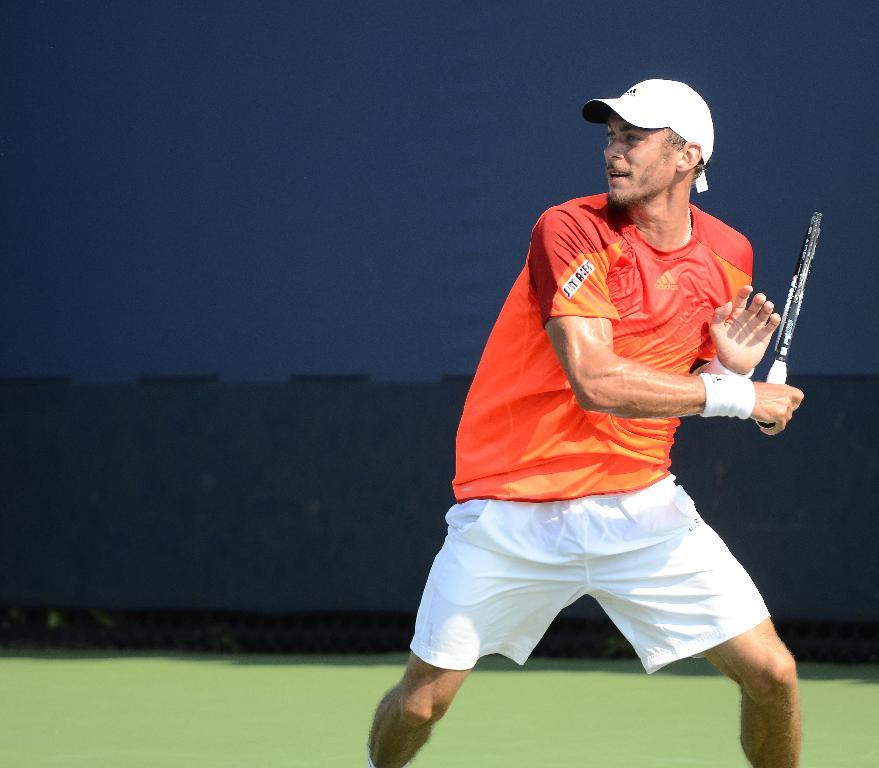Who or what is present in the image? There is a person in the image. Where is the person located? The person is standing in a court. What is the person holding? The person is holding a tennis bat. What is the person doing in the image? The person is in motion. What type of headwear is the person wearing? The person is wearing a cap. What type of truck is visible in the image? There is no truck present in the image. What kind of vessel is being used by the person in the image? The person is not using any vessel in the image; they are holding a tennis bat. 